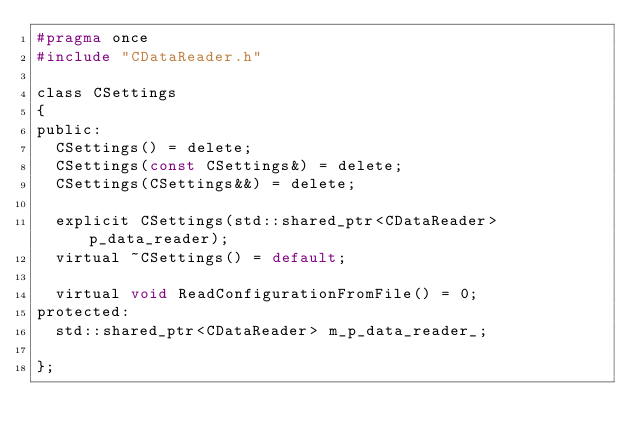<code> <loc_0><loc_0><loc_500><loc_500><_C_>#pragma once
#include "CDataReader.h"

class CSettings
{
public:
	CSettings() = delete;
	CSettings(const CSettings&) = delete;
	CSettings(CSettings&&) = delete;

	explicit CSettings(std::shared_ptr<CDataReader> p_data_reader);
	virtual ~CSettings() = default;

	virtual void ReadConfigurationFromFile() = 0;
protected:
	std::shared_ptr<CDataReader> m_p_data_reader_;

};
</code> 